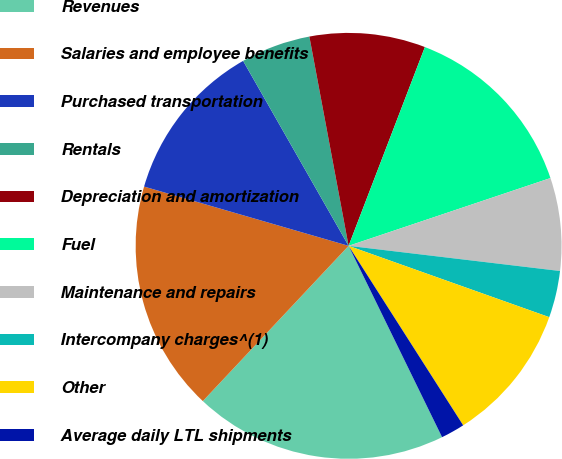Convert chart to OTSL. <chart><loc_0><loc_0><loc_500><loc_500><pie_chart><fcel>Revenues<fcel>Salaries and employee benefits<fcel>Purchased transportation<fcel>Rentals<fcel>Depreciation and amortization<fcel>Fuel<fcel>Maintenance and repairs<fcel>Intercompany charges^(1)<fcel>Other<fcel>Average daily LTL shipments<nl><fcel>19.23%<fcel>17.49%<fcel>12.26%<fcel>5.3%<fcel>8.78%<fcel>14.01%<fcel>7.04%<fcel>3.55%<fcel>10.52%<fcel>1.81%<nl></chart> 